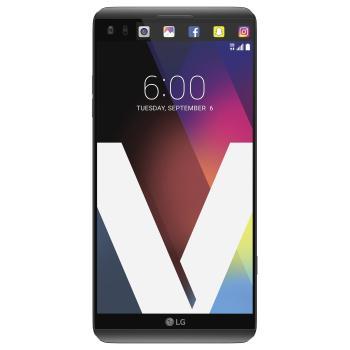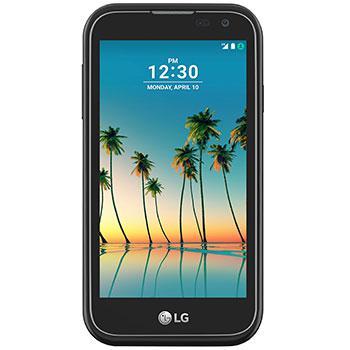The first image is the image on the left, the second image is the image on the right. Given the left and right images, does the statement "The phone on the left has a beach wallpaper, the phone on the right has an abstract wallpaper." hold true? Answer yes or no. No. The first image is the image on the left, the second image is the image on the right. Given the left and right images, does the statement "There are two full black phones." hold true? Answer yes or no. Yes. 